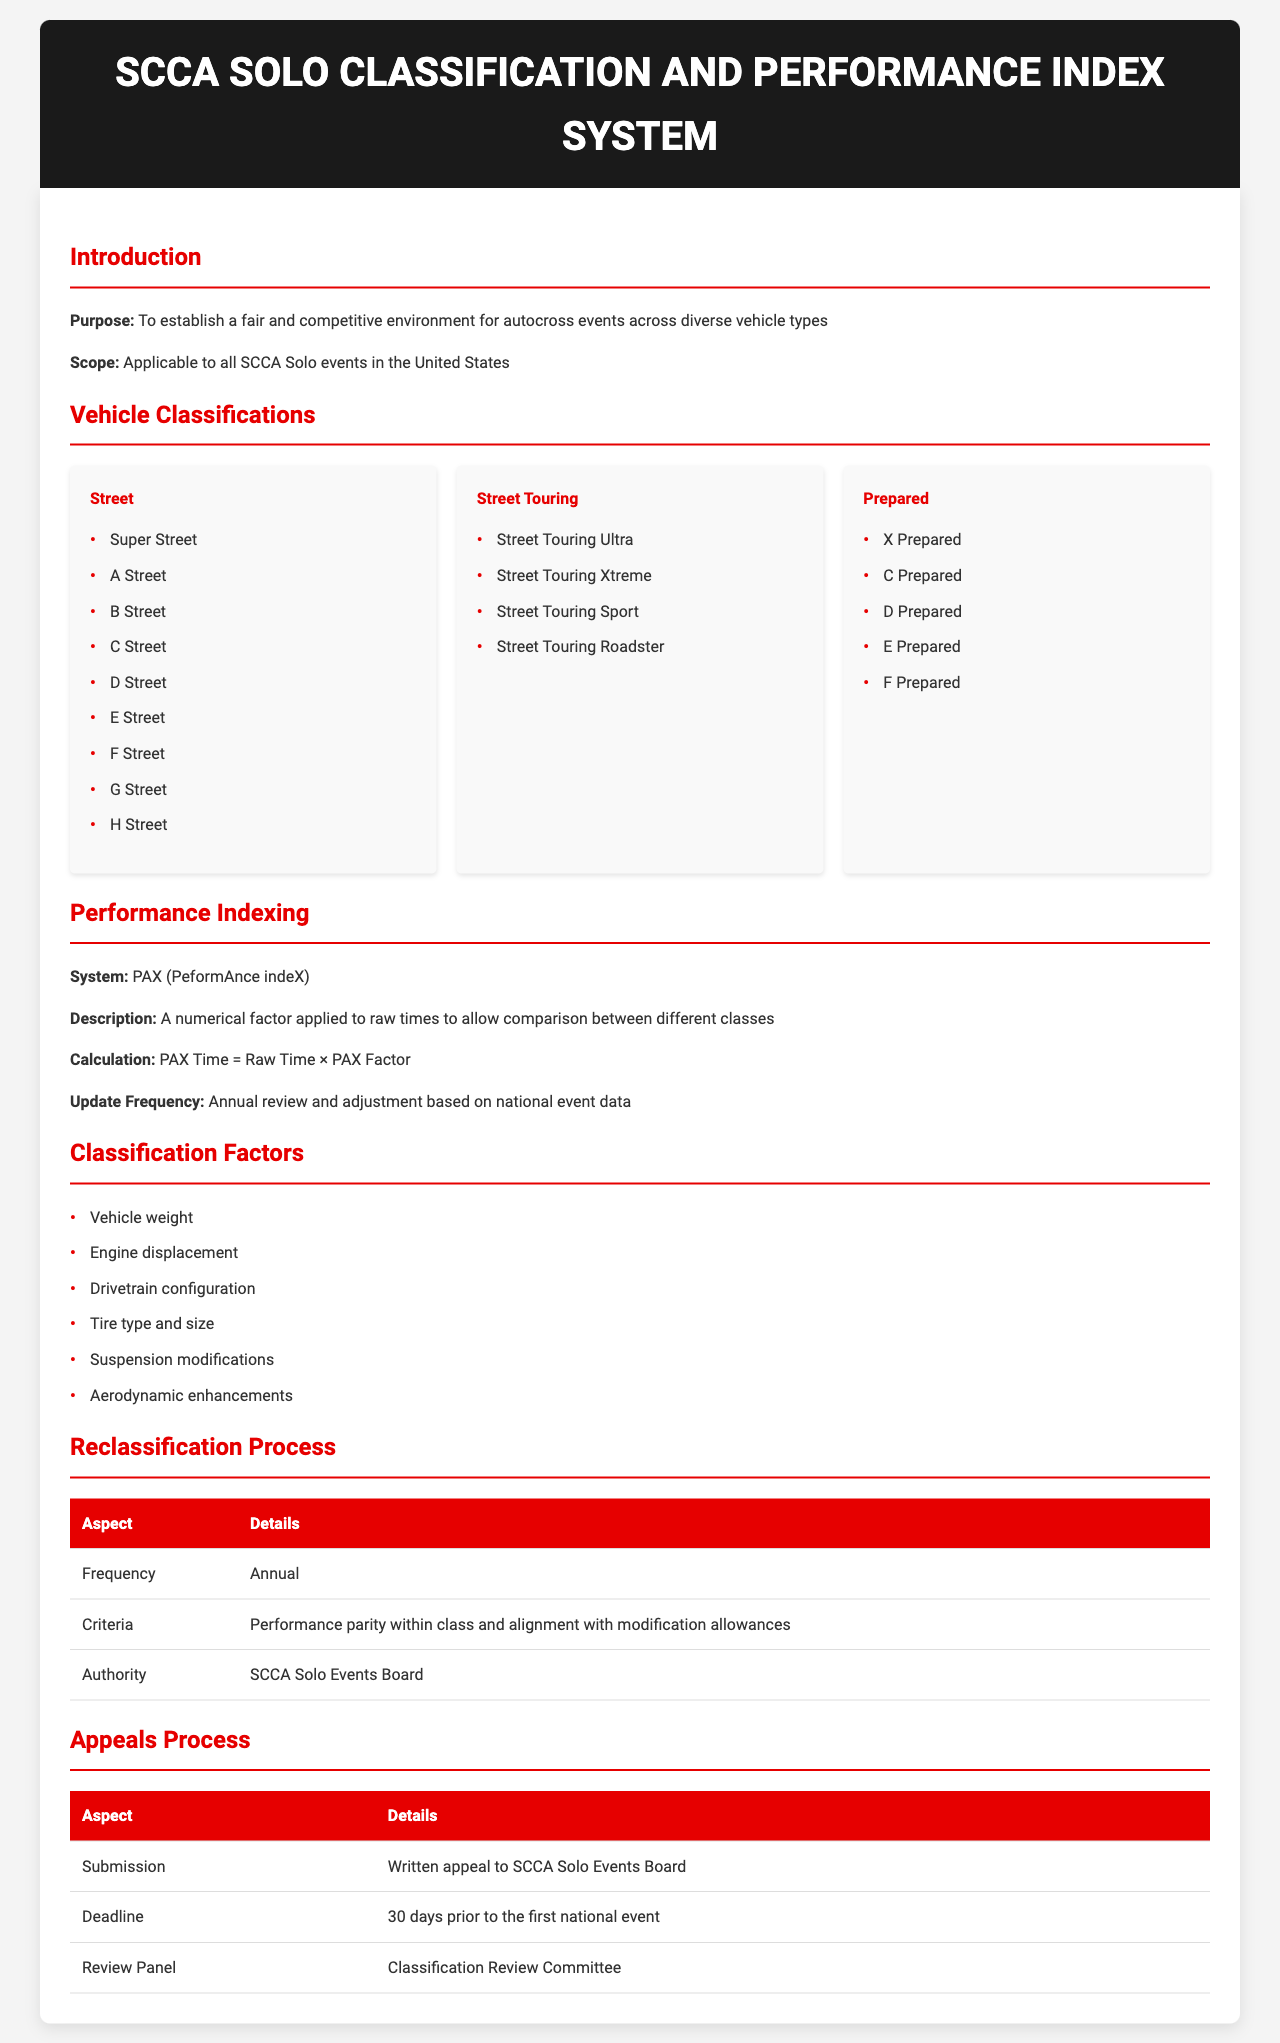What is the purpose of the document? The document's purpose is to establish a fair and competitive environment for autocross events across diverse vehicle types.
Answer: fair and competitive environment What are the vehicle classifications listed under 'Street'? The vehicle classifications under 'Street' include Super Street, A Street, B Street, C Street, D Street, E Street, F Street, G Street, and H Street.
Answer: Super Street, A Street, B Street, C Street, D Street, E Street, F Street, G Street, H Street What is the PAX factor used for? The PAX factor is a numerical factor applied to raw times to allow comparison between different classes.
Answer: comparison between different classes How often is the reclassification process conducted? The reclassification process is conducted annually.
Answer: Annual Who has the authority over the reclassification process? The authority over the reclassification process is held by the SCCA Solo Events Board.
Answer: SCCA Solo Events Board When is the deadline for submitting an appeal? The deadline for submitting an appeal is 30 days prior to the first national event.
Answer: 30 days prior to the first national event What are the criteria for reclassification? The criteria for reclassification include performance parity within class and alignment with modification allowances.
Answer: performance parity within class and alignment with modification allowances What does PAX stand for? PAX stands for PerformAnce indeX.
Answer: PerformAnce indeX 